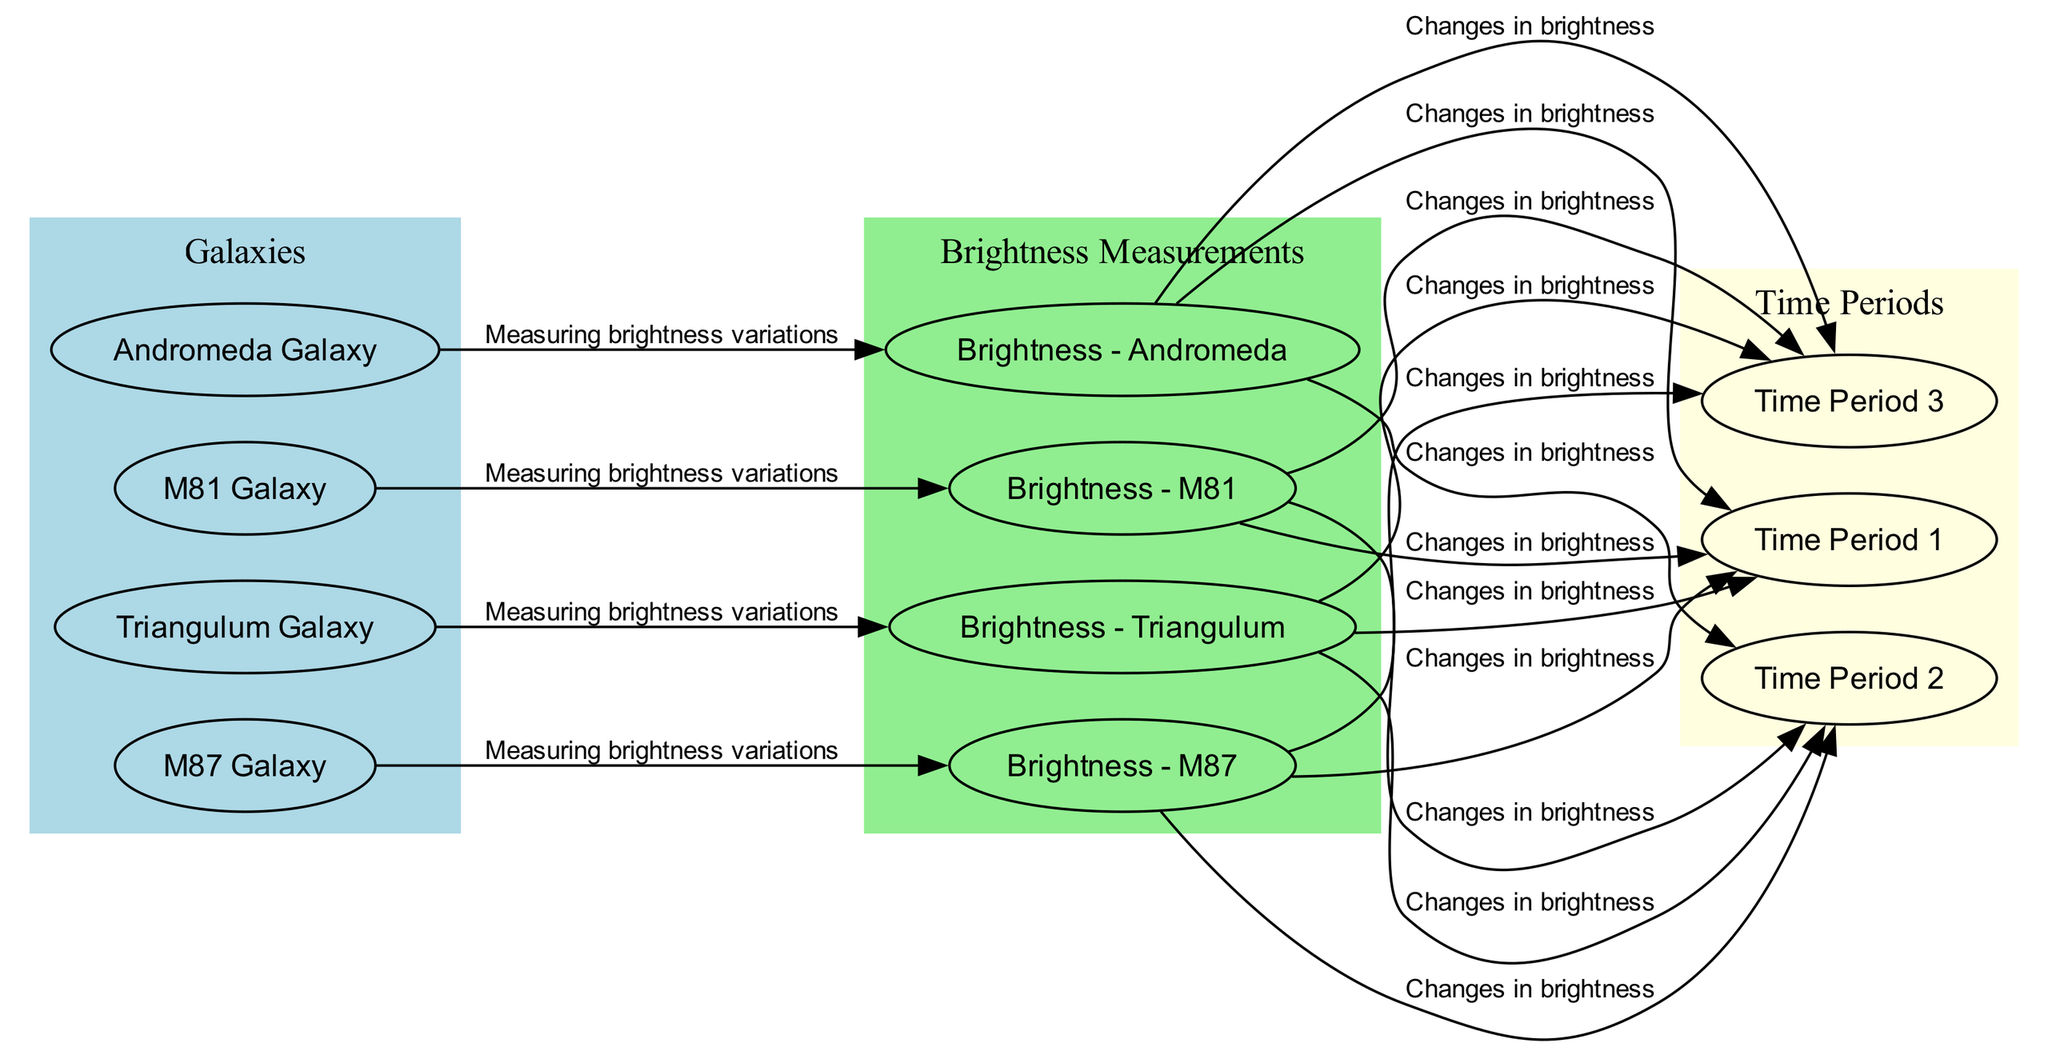What is the total number of galaxies represented in the diagram? The diagram includes four galaxy nodes: M87 Galaxy, Andromeda Galaxy, Triangulum Galaxy, and M81 Galaxy. Therefore, by counting these nodes, we find the total is four.
Answer: 4 Which galaxy has its brightness variations measured over three time periods? All galaxy nodes (M87, Andromeda, Triangulum, and M81) have their brightness variations measured across all three time periods indicated in the diagram. Therefore, the answer reflects the shared characteristic of these galaxies.
Answer: All of them What color represents the brightness measurements in the diagram? The brightness measurements are represented by the light green color, as specified in the graph's color coding.
Answer: Light green How many edges connect the M87 Galaxy to the brightness variations? The M87 Galaxy has three edges connecting it to the brightness measurements across Time Period 1, 2, and 3. This is determined by counting the edges that originate from the M87 node to the brightness nodes.
Answer: 3 Which galaxy is part of the Local Group? The Andromeda Galaxy and the Triangulum Galaxy are both classified as members of the Local Group, as described in their respective nodes.
Answer: Andromeda Galaxy What is the relationship represented by the edge from theBrightness - M87 to Time Period 1? The edge signifies the measurement of changes in brightness for M87 during the first observation period. This clarifies the connection between the brightness and time measurement.
Answer: Changes in brightness Which galaxy shows the greatest brightness variations over which time periods according to the diagram? The diagram does not provide specific numeric values for brightness or indicate which galaxy shows the greatest variations, only that there are changes noted across the time periods for all galaxies without specific comparison metrics. Therefore, the answer is indeterminate based on the visual information presented.
Answer: Indeterminate In how many observation periods are the brightness of the galaxies measured? The diagram includes three labeled time periods, which explicitly outlines the intervals for observing brightness changes. By counting, we find there are three time periods.
Answer: 3 Which galaxy is located in the Virgo Cluster? The M87 Galaxy is identified as being located in the Virgo Cluster, as given in its description. This specification directly links the galaxy to its well-known cluster.
Answer: M87 Galaxy 